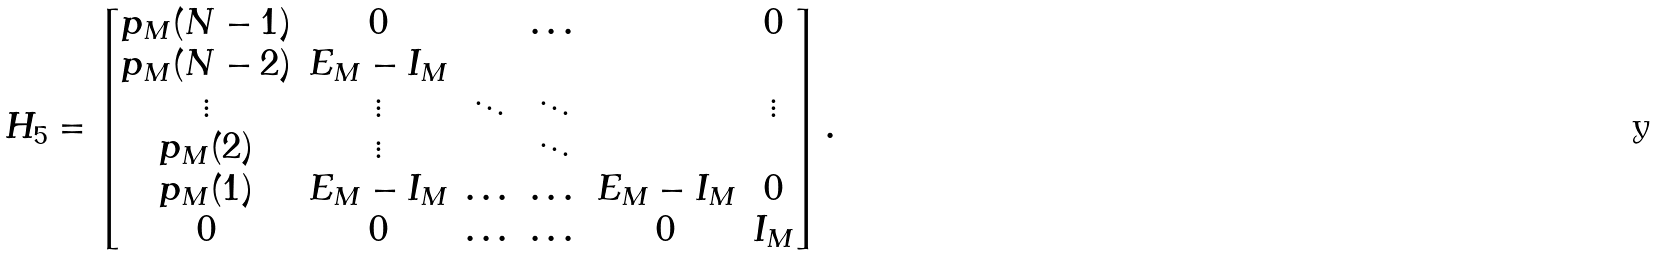Convert formula to latex. <formula><loc_0><loc_0><loc_500><loc_500>H _ { 5 } = \begin{bmatrix} p _ { M } ( N - 1 ) & 0 & & \dots & & 0 \\ p _ { M } ( N - 2 ) & E _ { M } - I _ { M } & & & & \\ \vdots & \vdots & \ddots & \ddots & & \vdots \\ p _ { M } ( 2 ) & \vdots & & \ddots & & \\ p _ { M } ( 1 ) & E _ { M } - I _ { M } & \dots & \dots & E _ { M } - I _ { M } & 0 \\ 0 & 0 & \dots & \dots & 0 & I _ { M } \end{bmatrix} .</formula> 